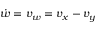Convert formula to latex. <formula><loc_0><loc_0><loc_500><loc_500>\dot { w } = v _ { w } = v _ { x } - v _ { y }</formula> 